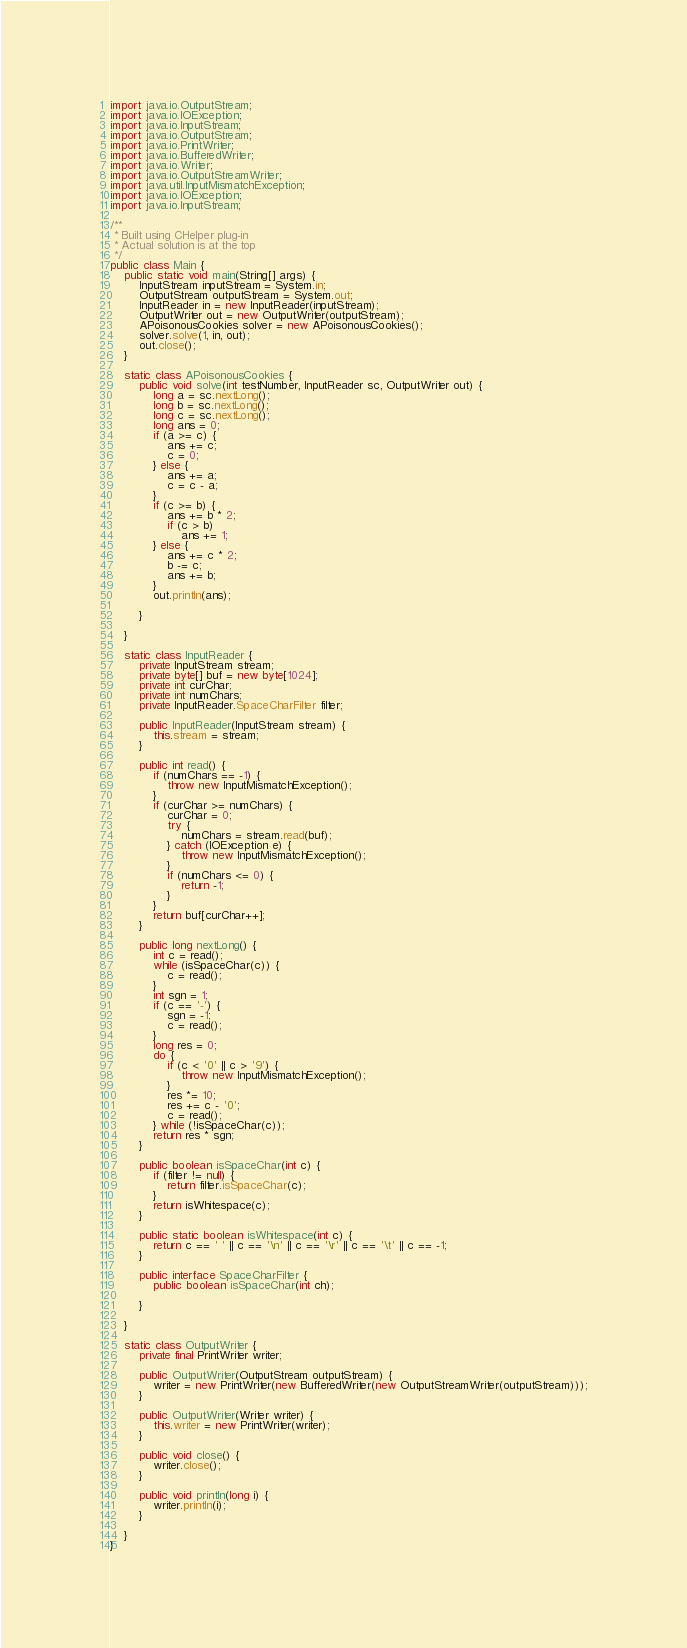<code> <loc_0><loc_0><loc_500><loc_500><_Java_>import java.io.OutputStream;
import java.io.IOException;
import java.io.InputStream;
import java.io.OutputStream;
import java.io.PrintWriter;
import java.io.BufferedWriter;
import java.io.Writer;
import java.io.OutputStreamWriter;
import java.util.InputMismatchException;
import java.io.IOException;
import java.io.InputStream;

/**
 * Built using CHelper plug-in
 * Actual solution is at the top
 */
public class Main {
    public static void main(String[] args) {
        InputStream inputStream = System.in;
        OutputStream outputStream = System.out;
        InputReader in = new InputReader(inputStream);
        OutputWriter out = new OutputWriter(outputStream);
        APoisonousCookies solver = new APoisonousCookies();
        solver.solve(1, in, out);
        out.close();
    }

    static class APoisonousCookies {
        public void solve(int testNumber, InputReader sc, OutputWriter out) {
            long a = sc.nextLong();
            long b = sc.nextLong();
            long c = sc.nextLong();
            long ans = 0;
            if (a >= c) {
                ans += c;
                c = 0;
            } else {
                ans += a;
                c = c - a;
            }
            if (c >= b) {
                ans += b * 2;
                if (c > b)
                    ans += 1;
            } else {
                ans += c * 2;
                b -= c;
                ans += b;
            }
            out.println(ans);

        }

    }

    static class InputReader {
        private InputStream stream;
        private byte[] buf = new byte[1024];
        private int curChar;
        private int numChars;
        private InputReader.SpaceCharFilter filter;

        public InputReader(InputStream stream) {
            this.stream = stream;
        }

        public int read() {
            if (numChars == -1) {
                throw new InputMismatchException();
            }
            if (curChar >= numChars) {
                curChar = 0;
                try {
                    numChars = stream.read(buf);
                } catch (IOException e) {
                    throw new InputMismatchException();
                }
                if (numChars <= 0) {
                    return -1;
                }
            }
            return buf[curChar++];
        }

        public long nextLong() {
            int c = read();
            while (isSpaceChar(c)) {
                c = read();
            }
            int sgn = 1;
            if (c == '-') {
                sgn = -1;
                c = read();
            }
            long res = 0;
            do {
                if (c < '0' || c > '9') {
                    throw new InputMismatchException();
                }
                res *= 10;
                res += c - '0';
                c = read();
            } while (!isSpaceChar(c));
            return res * sgn;
        }

        public boolean isSpaceChar(int c) {
            if (filter != null) {
                return filter.isSpaceChar(c);
            }
            return isWhitespace(c);
        }

        public static boolean isWhitespace(int c) {
            return c == ' ' || c == '\n' || c == '\r' || c == '\t' || c == -1;
        }

        public interface SpaceCharFilter {
            public boolean isSpaceChar(int ch);

        }

    }

    static class OutputWriter {
        private final PrintWriter writer;

        public OutputWriter(OutputStream outputStream) {
            writer = new PrintWriter(new BufferedWriter(new OutputStreamWriter(outputStream)));
        }

        public OutputWriter(Writer writer) {
            this.writer = new PrintWriter(writer);
        }

        public void close() {
            writer.close();
        }

        public void println(long i) {
            writer.println(i);
        }

    }
}

</code> 